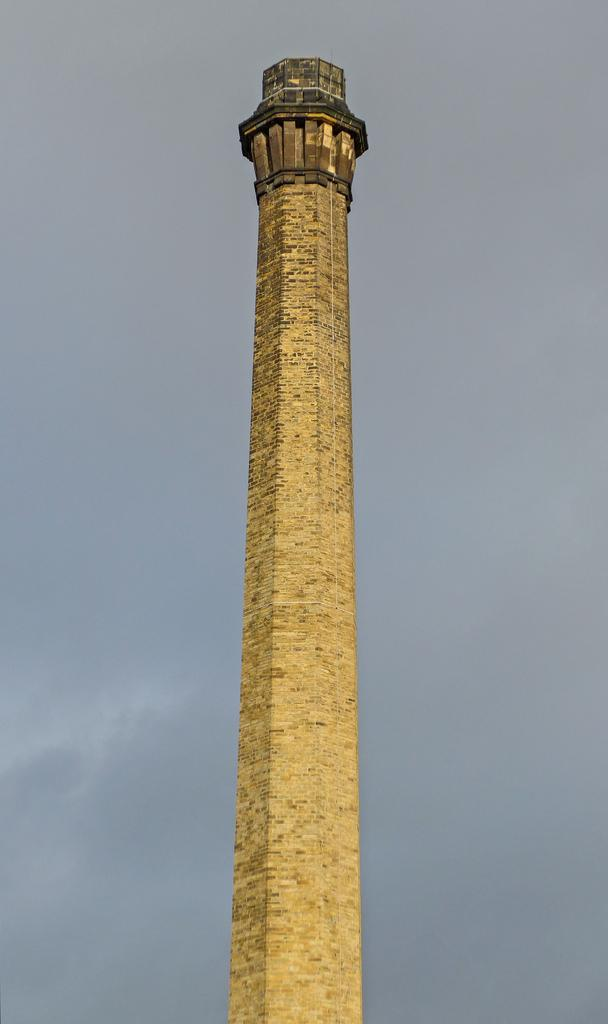What is the main structure in the image? There is a tower in the image. Where is the tower located? The tower is on the ground. What can be seen in the sky in the image? There are clouds visible in the sky. Where is the key to the playground located in the image? There is no playground or key present in the image; it only features a tower and clouds in the sky. How many ducks are swimming in the water near the tower in the image? There are no ducks or water present in the image; it only features a tower and clouds in the sky. 